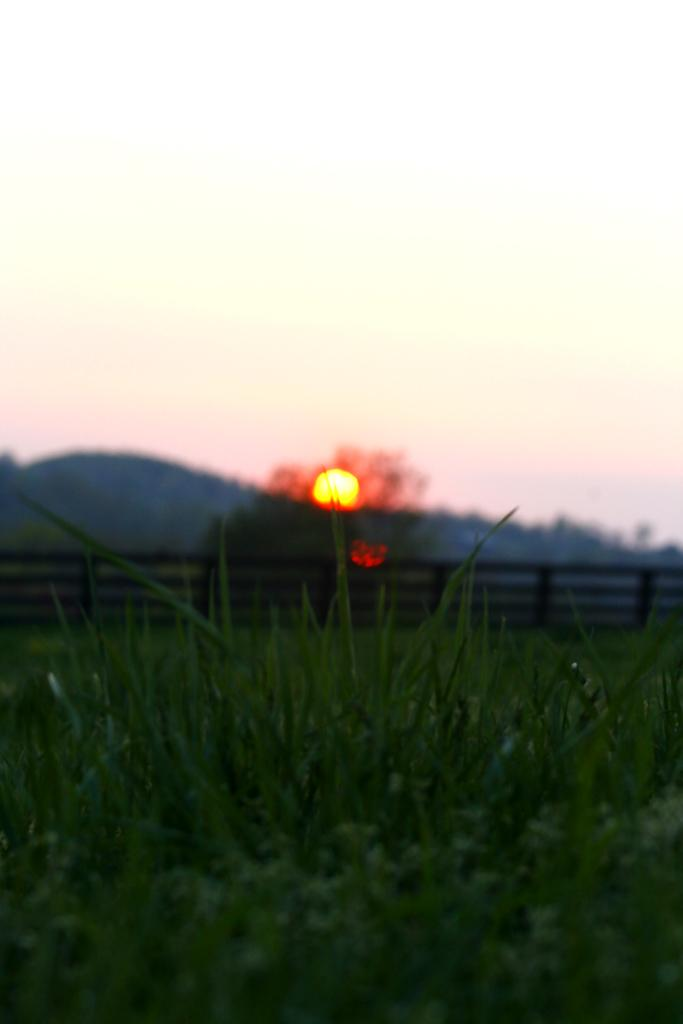What type of vegetation is present on the ground in the image? There is green color grass on the ground in the image. What structure can be seen in the image? There is a railing in the image. What can be seen in the distance in the image? There is a hill in the background of the image. What is visible in the sky in the image? The sky is visible in the background of the image, and the sun is observable in the sky. What type of bird can be seen in the jail in the image? There is no bird or jail present in the image; it features green grass, a railing, a hill, and the sky. 